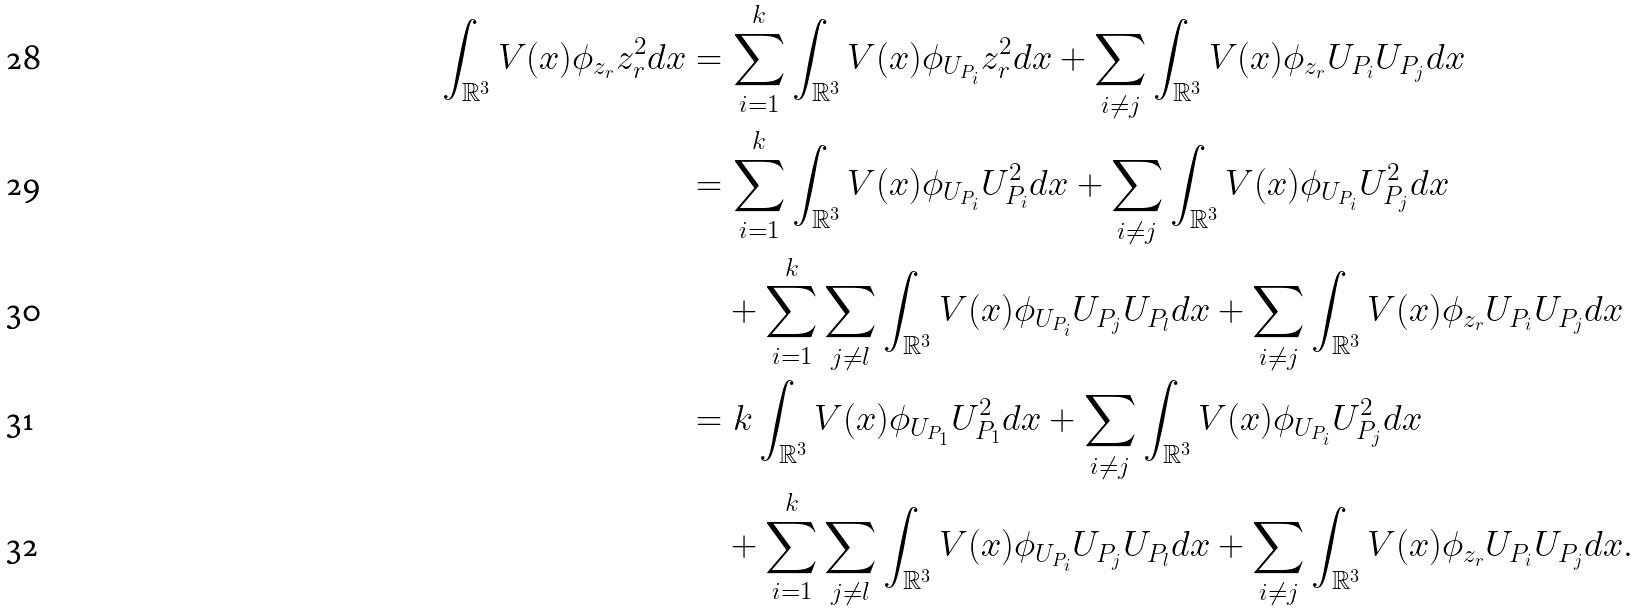Convert formula to latex. <formula><loc_0><loc_0><loc_500><loc_500>\int _ { \mathbb { R } ^ { 3 } } V ( x ) \phi _ { z _ { r } } z _ { r } ^ { 2 } d x & = \sum _ { i = 1 } ^ { k } \int _ { \mathbb { R } ^ { 3 } } V ( x ) \phi _ { U _ { P _ { i } } } z _ { r } ^ { 2 } d x + \sum _ { i \neq j } \int _ { \mathbb { R } ^ { 3 } } V ( x ) \phi _ { z _ { r } } U _ { P _ { i } } U _ { P _ { j } } d x \\ & = \sum _ { i = 1 } ^ { k } \int _ { \mathbb { R } ^ { 3 } } V ( x ) \phi _ { U _ { P _ { i } } } U _ { P _ { i } } ^ { 2 } d x + \sum _ { i \neq j } \int _ { \mathbb { R } ^ { 3 } } V ( x ) \phi _ { U _ { P _ { i } } } U _ { P _ { j } } ^ { 2 } d x \\ & \quad + \sum _ { i = 1 } ^ { k } \sum _ { j \neq l } \int _ { \mathbb { R } ^ { 3 } } V ( x ) \phi _ { U _ { P _ { i } } } U _ { P _ { j } } U _ { P _ { l } } d x + \sum _ { i \neq j } \int _ { \mathbb { R } ^ { 3 } } V ( x ) \phi _ { z _ { r } } U _ { P _ { i } } U _ { P _ { j } } d x \\ & = k \int _ { \mathbb { R } ^ { 3 } } V ( x ) \phi _ { U _ { P _ { 1 } } } U _ { P _ { 1 } } ^ { 2 } d x + \sum _ { i \neq j } \int _ { \mathbb { R } ^ { 3 } } V ( x ) \phi _ { U _ { P _ { i } } } U _ { P _ { j } } ^ { 2 } d x \\ & \quad + \sum _ { i = 1 } ^ { k } \sum _ { j \neq l } \int _ { \mathbb { R } ^ { 3 } } V ( x ) \phi _ { U _ { P _ { i } } } U _ { P _ { j } } U _ { P _ { l } } d x + \sum _ { i \neq j } \int _ { \mathbb { R } ^ { 3 } } V ( x ) \phi _ { z _ { r } } U _ { P _ { i } } U _ { P _ { j } } d x .</formula> 